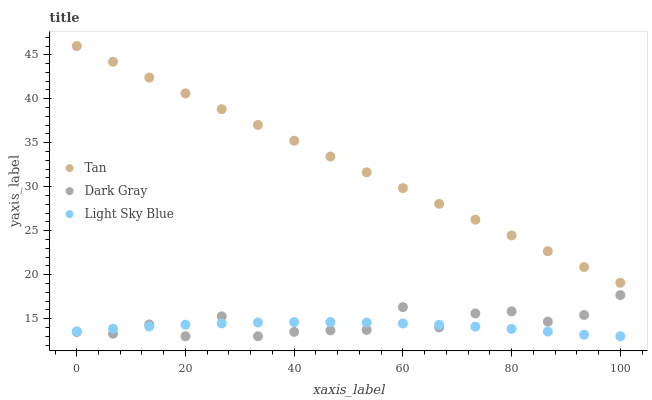Does Light Sky Blue have the minimum area under the curve?
Answer yes or no. Yes. Does Tan have the maximum area under the curve?
Answer yes or no. Yes. Does Tan have the minimum area under the curve?
Answer yes or no. No. Does Light Sky Blue have the maximum area under the curve?
Answer yes or no. No. Is Tan the smoothest?
Answer yes or no. Yes. Is Dark Gray the roughest?
Answer yes or no. Yes. Is Light Sky Blue the smoothest?
Answer yes or no. No. Is Light Sky Blue the roughest?
Answer yes or no. No. Does Dark Gray have the lowest value?
Answer yes or no. Yes. Does Tan have the lowest value?
Answer yes or no. No. Does Tan have the highest value?
Answer yes or no. Yes. Does Light Sky Blue have the highest value?
Answer yes or no. No. Is Light Sky Blue less than Tan?
Answer yes or no. Yes. Is Tan greater than Light Sky Blue?
Answer yes or no. Yes. Does Dark Gray intersect Light Sky Blue?
Answer yes or no. Yes. Is Dark Gray less than Light Sky Blue?
Answer yes or no. No. Is Dark Gray greater than Light Sky Blue?
Answer yes or no. No. Does Light Sky Blue intersect Tan?
Answer yes or no. No. 